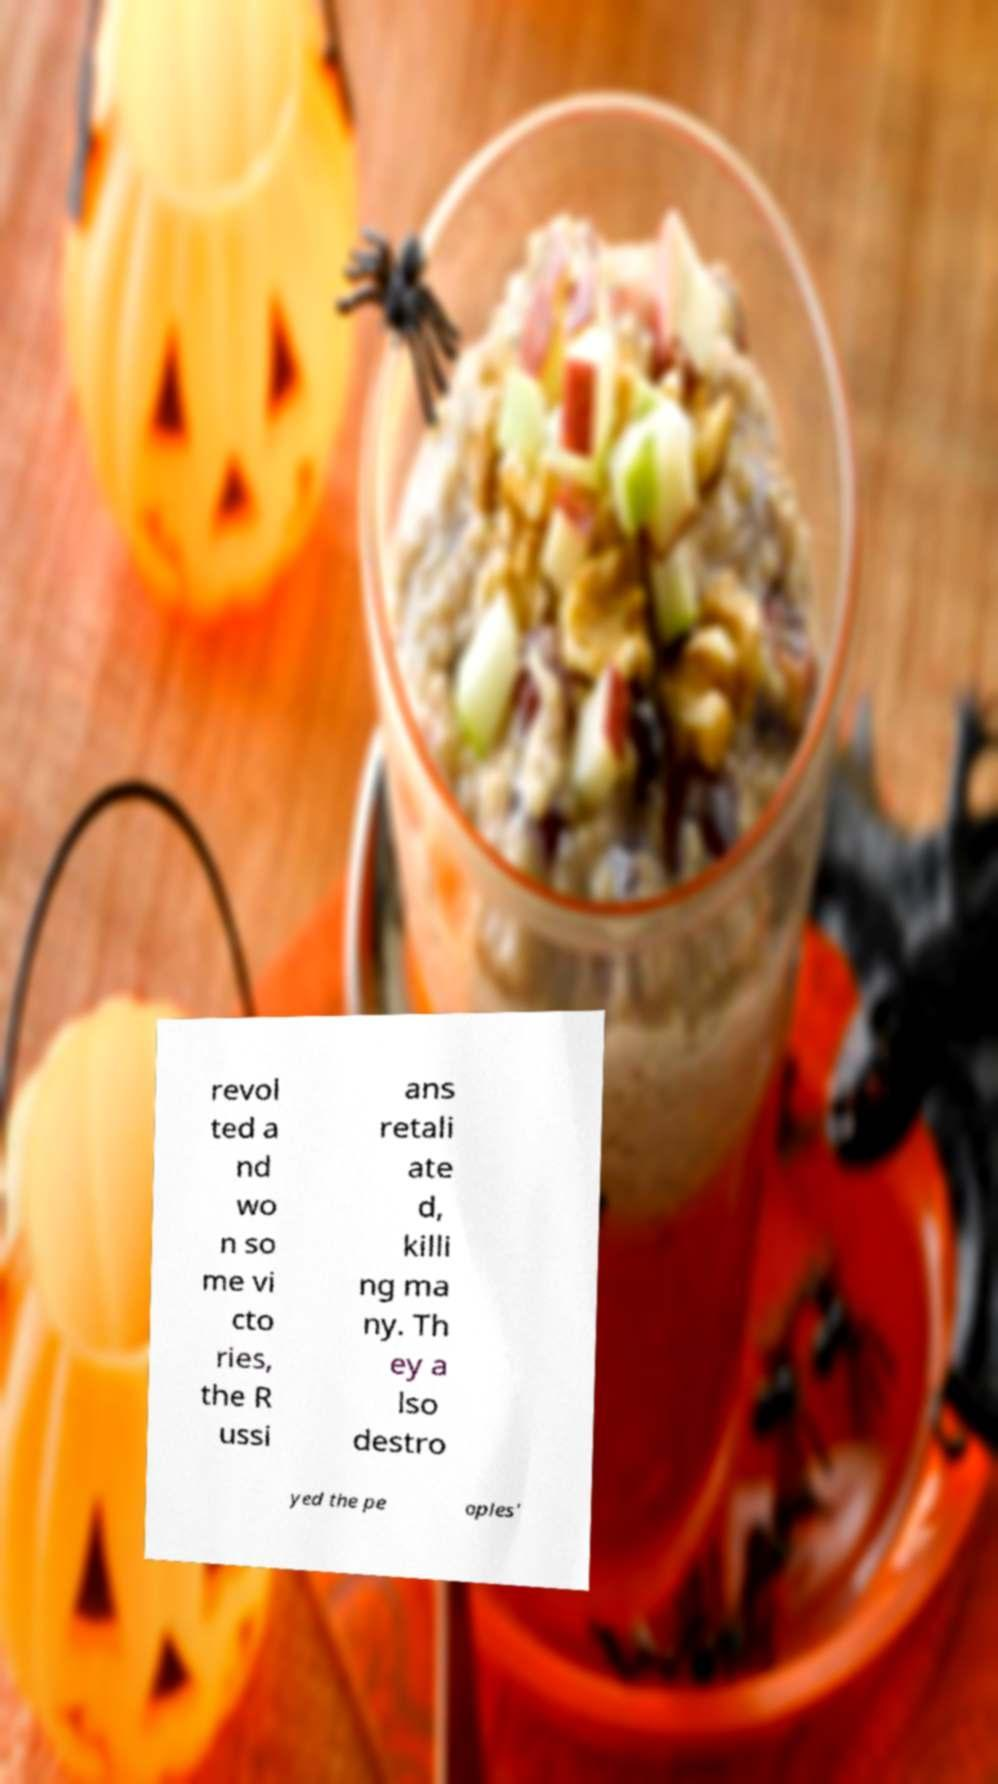Can you accurately transcribe the text from the provided image for me? revol ted a nd wo n so me vi cto ries, the R ussi ans retali ate d, killi ng ma ny. Th ey a lso destro yed the pe oples' 